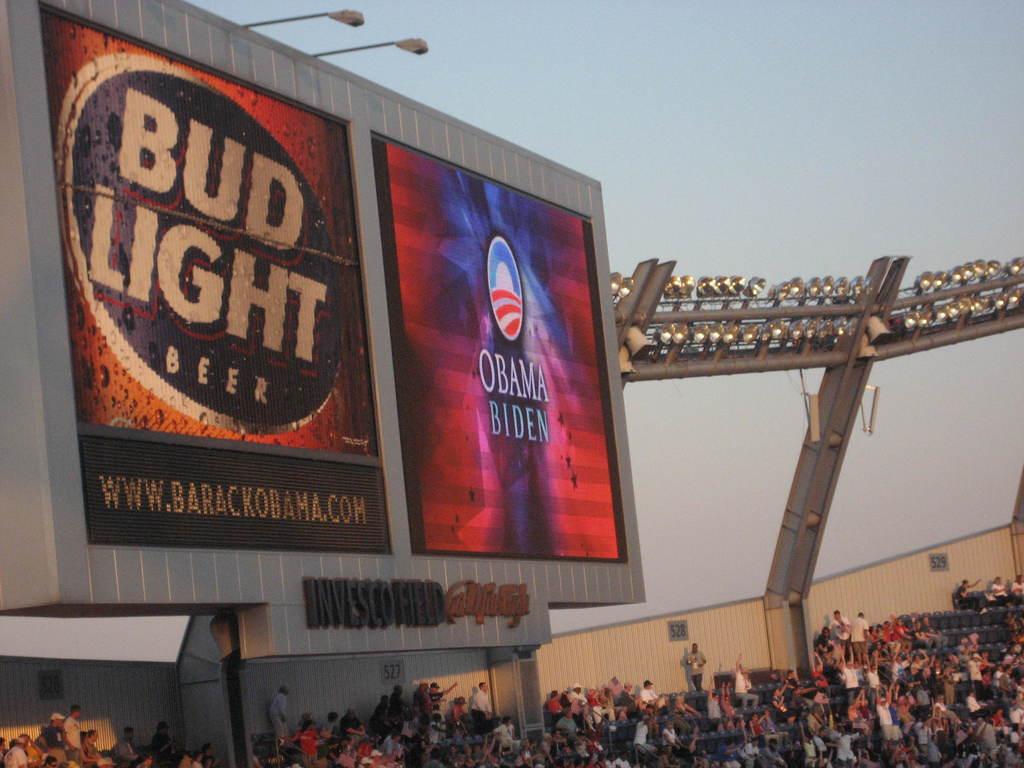What brand of beer is being advertised on the screen?
Ensure brevity in your answer.  Bud light. What is the contact information?
Offer a terse response. Www.barackobama.com. 